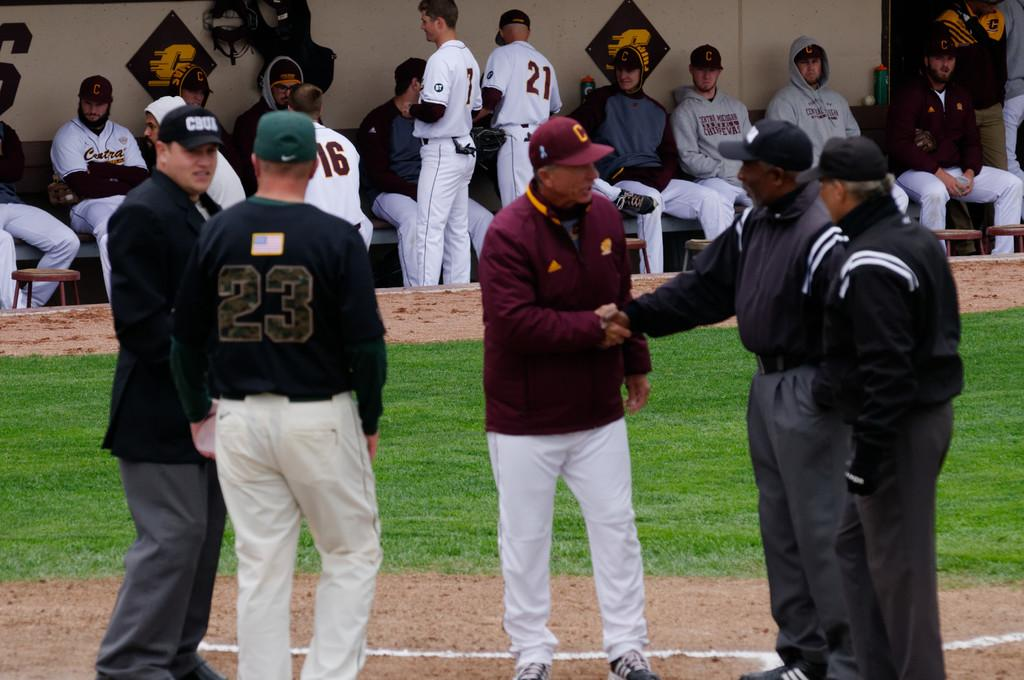<image>
Create a compact narrative representing the image presented. An umpire, wearing a hat labelled CBUA, talks with someone wearing the jersey number 23. 